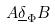Convert formula to latex. <formula><loc_0><loc_0><loc_500><loc_500>A \underline { \delta } _ { \Phi } B</formula> 